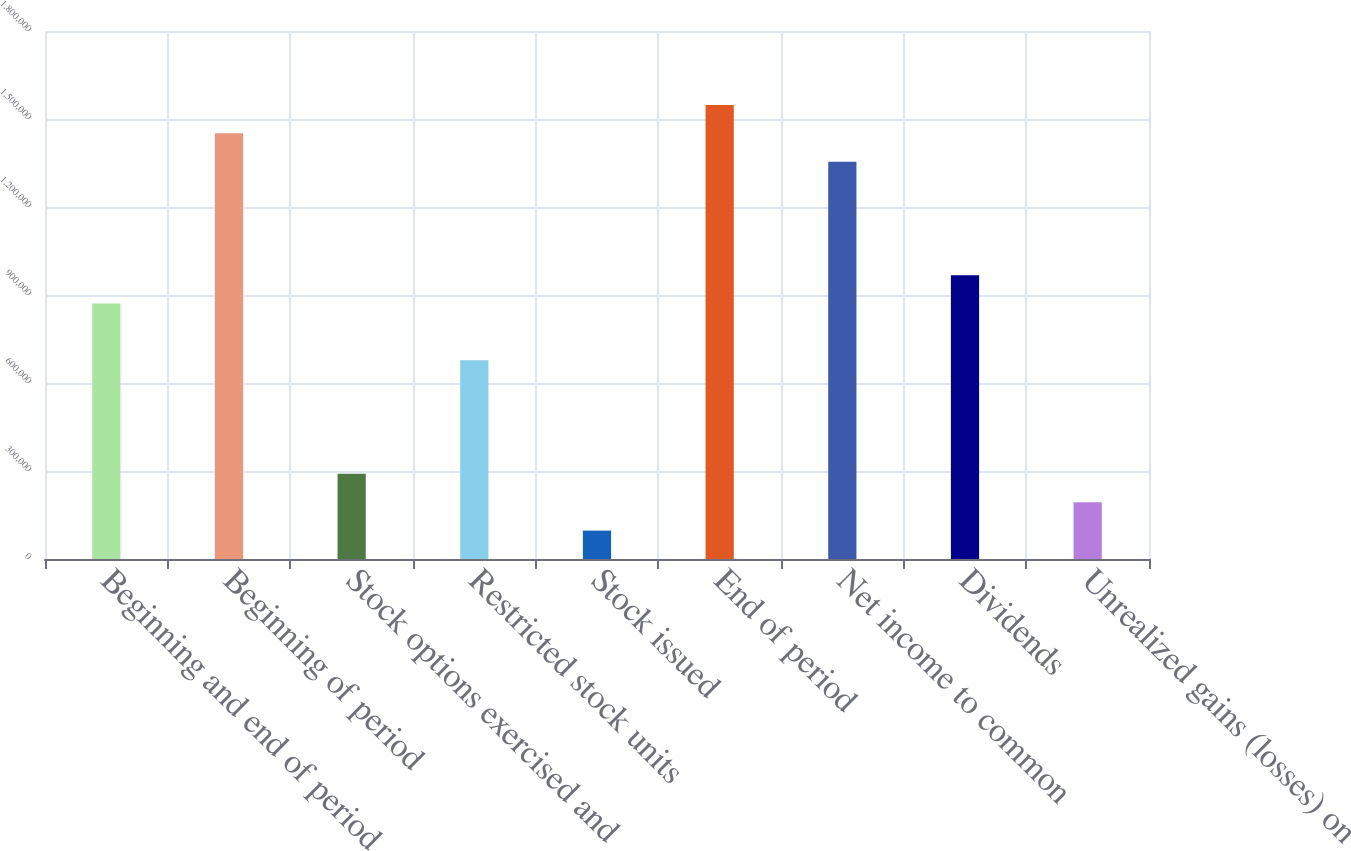Convert chart. <chart><loc_0><loc_0><loc_500><loc_500><bar_chart><fcel>Beginning and end of period<fcel>Beginning of period<fcel>Stock options exercised and<fcel>Restricted stock units<fcel>Stock issued<fcel>End of period<fcel>Net income to common<fcel>Dividends<fcel>Unrealized gains (losses) on<nl><fcel>870699<fcel>1.45115e+06<fcel>290252<fcel>677216<fcel>96769.2<fcel>1.54789e+06<fcel>1.3544e+06<fcel>967440<fcel>193510<nl></chart> 